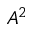<formula> <loc_0><loc_0><loc_500><loc_500>A ^ { 2 }</formula> 